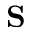Convert formula to latex. <formula><loc_0><loc_0><loc_500><loc_500>S</formula> 